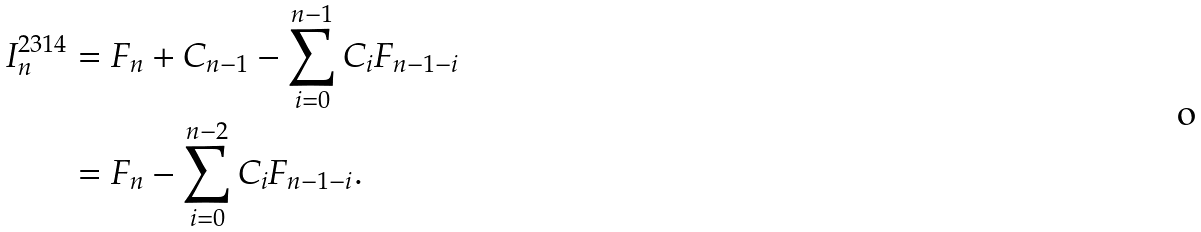Convert formula to latex. <formula><loc_0><loc_0><loc_500><loc_500>I ^ { 2 3 1 4 } _ { n } & = F _ { n } + C _ { n - 1 } - \sum _ { i = 0 } ^ { n - 1 } C _ { i } F _ { n - 1 - i } \\ & = F _ { n } - \sum _ { i = 0 } ^ { n - 2 } C _ { i } F _ { n - 1 - i } .</formula> 